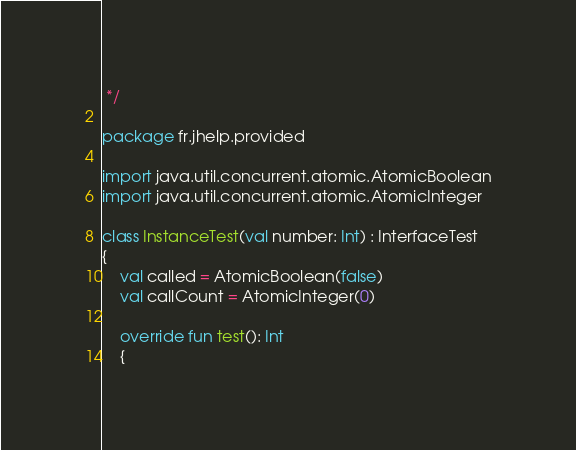Convert code to text. <code><loc_0><loc_0><loc_500><loc_500><_Kotlin_> */

package fr.jhelp.provided

import java.util.concurrent.atomic.AtomicBoolean
import java.util.concurrent.atomic.AtomicInteger

class InstanceTest(val number: Int) : InterfaceTest
{
    val called = AtomicBoolean(false)
    val callCount = AtomicInteger(0)

    override fun test(): Int
    {</code> 